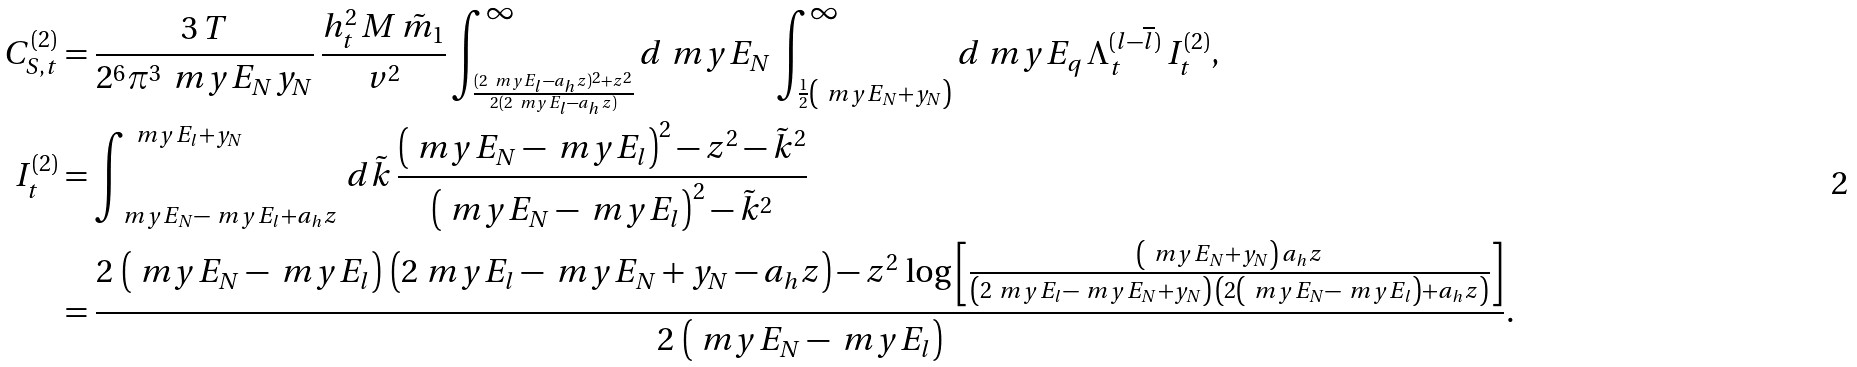<formula> <loc_0><loc_0><loc_500><loc_500>C _ { S , t } ^ { ( 2 ) } & = \frac { 3 \, T } { 2 ^ { 6 } \pi ^ { 3 } \, \ m y E _ { N } y _ { N } } \, \frac { h _ { t } ^ { 2 } \, M \, \tilde { m } _ { 1 } } { v ^ { 2 } } \int _ { \frac { ( 2 \ m y E _ { l } - a _ { h } z ) ^ { 2 } + z ^ { 2 } } { 2 ( 2 \ m y E _ { l } - a _ { h } z ) } } ^ { \infty } d \ m y E _ { N } \int _ { \frac { 1 } { 2 } \left ( \ m y E _ { N } + y _ { N } \right ) } ^ { \infty } d \ m y E _ { q } \, \Lambda _ { t } ^ { ( l - \overline { l } ) } \, I _ { t } ^ { ( 2 ) } , \\ I _ { t } ^ { ( 2 ) } & = \int _ { \ m y E _ { N } - \ m y E _ { l } + a _ { h } z } ^ { \ m y E _ { l } + y _ { N } } \, d \tilde { k } \, \frac { \left ( \ m y E _ { N } - \ m y E _ { l } \right ) ^ { 2 } - z ^ { 2 } - \tilde { k } ^ { 2 } } { \left ( \ m y E _ { N } - \ m y E _ { l } \right ) ^ { 2 } - \tilde { k } ^ { 2 } } \\ & = \frac { 2 \, \left ( \ m y E _ { N } - \ m y E _ { l } \right ) \, \left ( 2 \ m y E _ { l } - \ m y E _ { N } + y _ { N } - a _ { h } z \right ) - z ^ { 2 } \, \log \left [ \frac { \left ( \ m y E _ { N } + y _ { N } \right ) \, a _ { h } z } { \left ( 2 \ m y E _ { l } - \ m y E _ { N } + y _ { N } \right ) \, \left ( 2 \left ( \ m y E _ { N } - \ m y E _ { l } \right ) + a _ { h } z \right ) } \right ] } { 2 \, \left ( \ m y E _ { N } - \ m y E _ { l } \right ) } .</formula> 